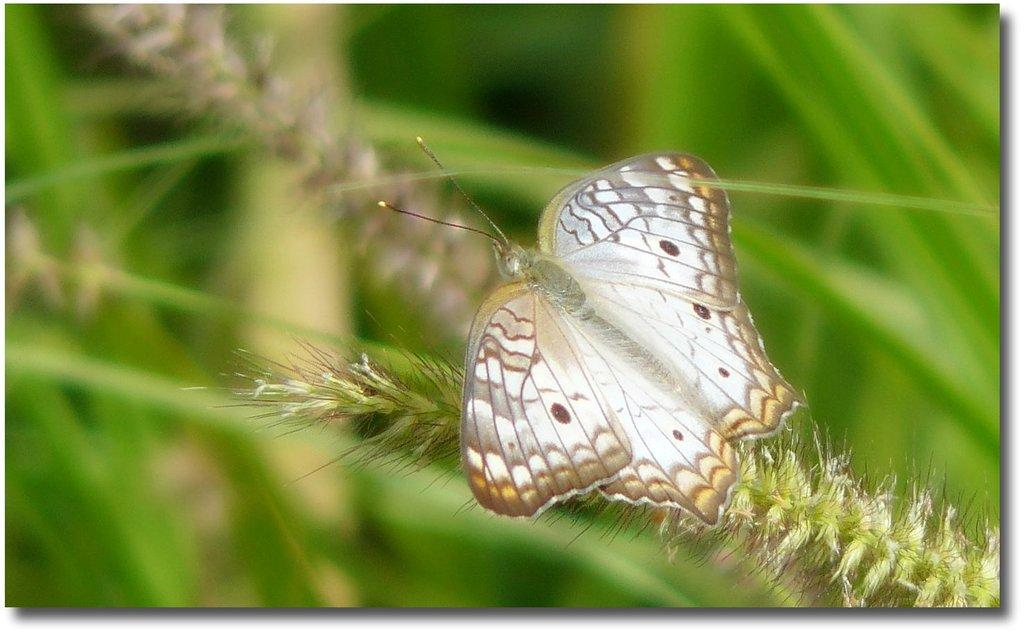What is the main subject of the image? There is a butterfly in the image. What can be seen in the background of the image? There are plants in the background of the image. What type of bun is the butterfly using to fly in the image? There is no bun present in the image, and butterflies do not use buns to fly. 